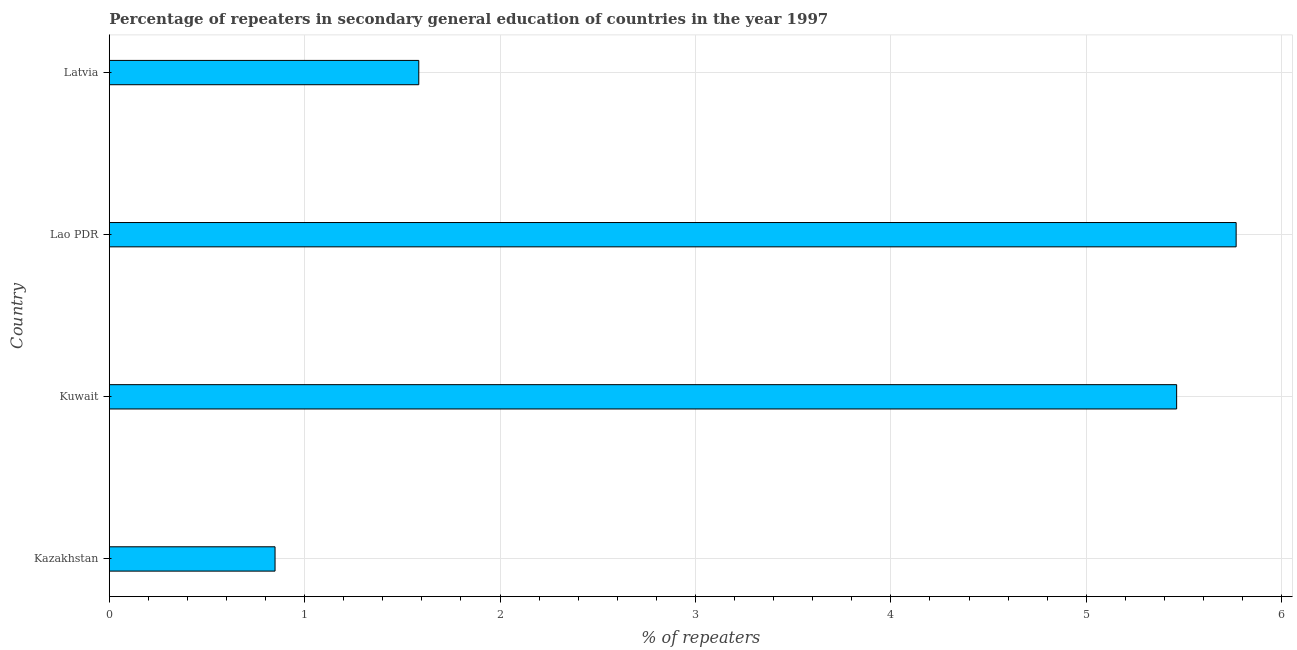Does the graph contain any zero values?
Your response must be concise. No. Does the graph contain grids?
Offer a terse response. Yes. What is the title of the graph?
Provide a succinct answer. Percentage of repeaters in secondary general education of countries in the year 1997. What is the label or title of the X-axis?
Offer a terse response. % of repeaters. What is the percentage of repeaters in Lao PDR?
Keep it short and to the point. 5.77. Across all countries, what is the maximum percentage of repeaters?
Give a very brief answer. 5.77. Across all countries, what is the minimum percentage of repeaters?
Offer a terse response. 0.85. In which country was the percentage of repeaters maximum?
Your response must be concise. Lao PDR. In which country was the percentage of repeaters minimum?
Ensure brevity in your answer.  Kazakhstan. What is the sum of the percentage of repeaters?
Your answer should be compact. 13.66. What is the difference between the percentage of repeaters in Kazakhstan and Kuwait?
Offer a very short reply. -4.61. What is the average percentage of repeaters per country?
Your response must be concise. 3.42. What is the median percentage of repeaters?
Your answer should be very brief. 3.52. In how many countries, is the percentage of repeaters greater than 3.8 %?
Keep it short and to the point. 2. What is the ratio of the percentage of repeaters in Kazakhstan to that in Lao PDR?
Ensure brevity in your answer.  0.15. What is the difference between the highest and the second highest percentage of repeaters?
Ensure brevity in your answer.  0.3. What is the difference between the highest and the lowest percentage of repeaters?
Ensure brevity in your answer.  4.92. In how many countries, is the percentage of repeaters greater than the average percentage of repeaters taken over all countries?
Make the answer very short. 2. How many bars are there?
Provide a succinct answer. 4. How many countries are there in the graph?
Make the answer very short. 4. What is the difference between two consecutive major ticks on the X-axis?
Keep it short and to the point. 1. What is the % of repeaters in Kazakhstan?
Your response must be concise. 0.85. What is the % of repeaters in Kuwait?
Offer a terse response. 5.46. What is the % of repeaters of Lao PDR?
Ensure brevity in your answer.  5.77. What is the % of repeaters in Latvia?
Provide a short and direct response. 1.58. What is the difference between the % of repeaters in Kazakhstan and Kuwait?
Offer a very short reply. -4.61. What is the difference between the % of repeaters in Kazakhstan and Lao PDR?
Your answer should be compact. -4.92. What is the difference between the % of repeaters in Kazakhstan and Latvia?
Your answer should be very brief. -0.74. What is the difference between the % of repeaters in Kuwait and Lao PDR?
Your response must be concise. -0.3. What is the difference between the % of repeaters in Kuwait and Latvia?
Keep it short and to the point. 3.88. What is the difference between the % of repeaters in Lao PDR and Latvia?
Give a very brief answer. 4.18. What is the ratio of the % of repeaters in Kazakhstan to that in Kuwait?
Your answer should be compact. 0.15. What is the ratio of the % of repeaters in Kazakhstan to that in Lao PDR?
Provide a short and direct response. 0.15. What is the ratio of the % of repeaters in Kazakhstan to that in Latvia?
Your answer should be very brief. 0.54. What is the ratio of the % of repeaters in Kuwait to that in Lao PDR?
Ensure brevity in your answer.  0.95. What is the ratio of the % of repeaters in Kuwait to that in Latvia?
Offer a very short reply. 3.45. What is the ratio of the % of repeaters in Lao PDR to that in Latvia?
Your answer should be compact. 3.64. 